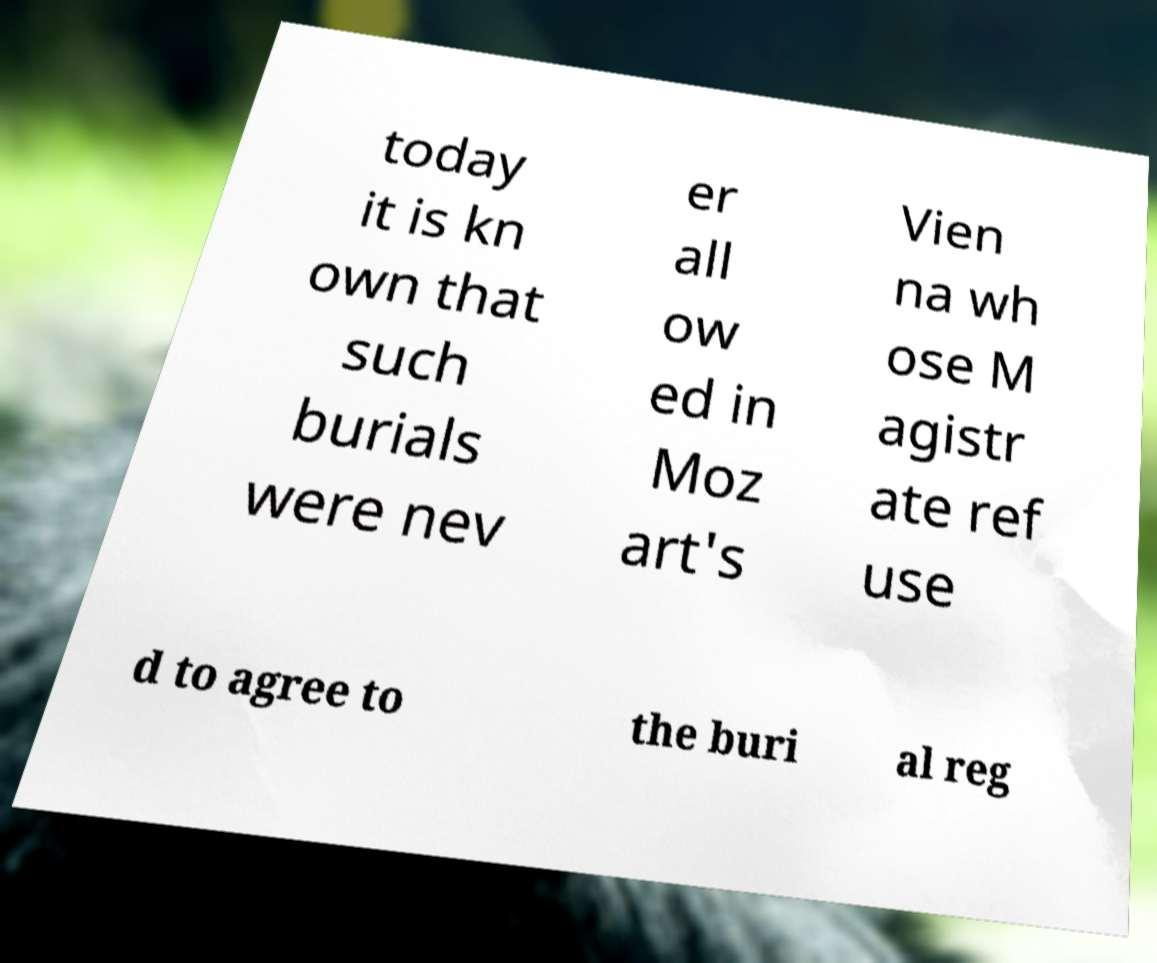Could you assist in decoding the text presented in this image and type it out clearly? today it is kn own that such burials were nev er all ow ed in Moz art's Vien na wh ose M agistr ate ref use d to agree to the buri al reg 